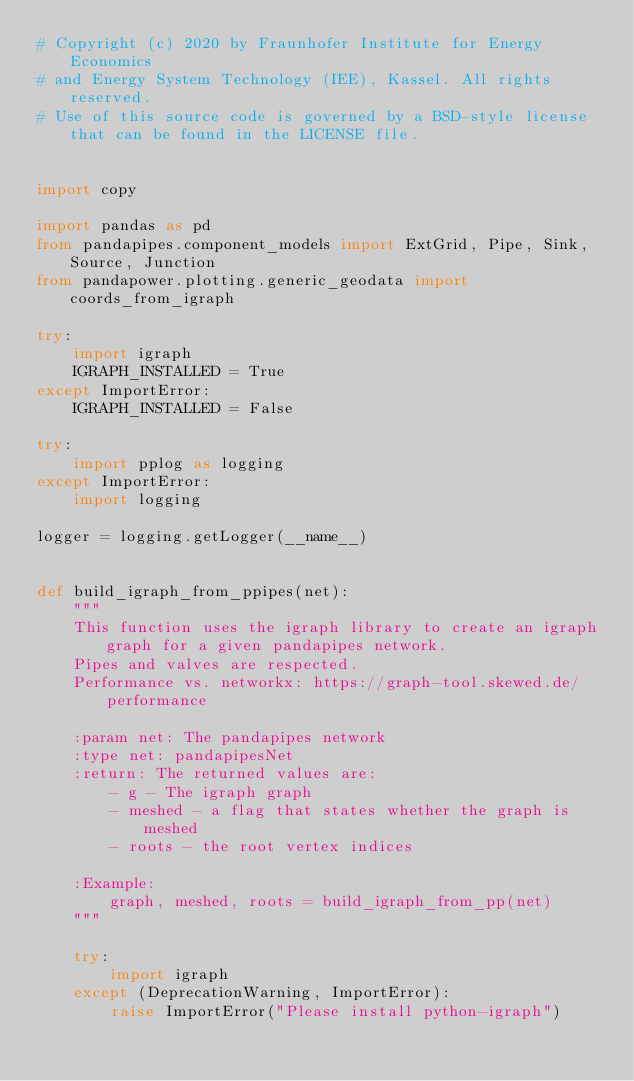Convert code to text. <code><loc_0><loc_0><loc_500><loc_500><_Python_># Copyright (c) 2020 by Fraunhofer Institute for Energy Economics
# and Energy System Technology (IEE), Kassel. All rights reserved.
# Use of this source code is governed by a BSD-style license that can be found in the LICENSE file.


import copy

import pandas as pd
from pandapipes.component_models import ExtGrid, Pipe, Sink, Source, Junction
from pandapower.plotting.generic_geodata import coords_from_igraph

try:
    import igraph
    IGRAPH_INSTALLED = True
except ImportError:
    IGRAPH_INSTALLED = False

try:
    import pplog as logging
except ImportError:
    import logging

logger = logging.getLogger(__name__)


def build_igraph_from_ppipes(net):
    """
    This function uses the igraph library to create an igraph graph for a given pandapipes network.
    Pipes and valves are respected.
    Performance vs. networkx: https://graph-tool.skewed.de/performance

    :param net: The pandapipes network
    :type net: pandapipesNet
    :return: The returned values are:
        - g - The igraph graph
        - meshed - a flag that states whether the graph is meshed
        - roots - the root vertex indices

    :Example:
        graph, meshed, roots = build_igraph_from_pp(net)
    """

    try:
        import igraph
    except (DeprecationWarning, ImportError):
        raise ImportError("Please install python-igraph")</code> 